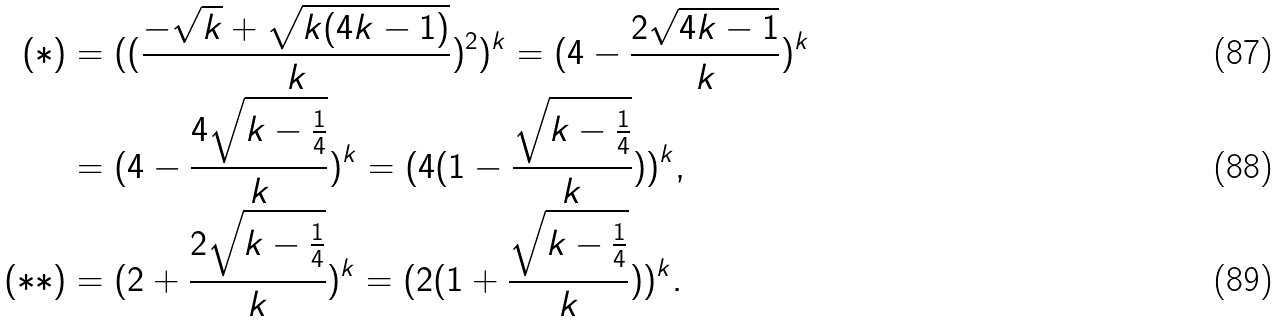<formula> <loc_0><loc_0><loc_500><loc_500>( * ) & = ( ( \frac { - \sqrt { k } + \sqrt { k ( 4 k - 1 ) } } { k } ) ^ { 2 } ) ^ { k } = ( 4 - \frac { 2 \sqrt { 4 k - 1 } } { k } ) ^ { k } \\ & = ( 4 - \frac { 4 \sqrt { k - \frac { 1 } { 4 } } } { k } ) ^ { k } = ( 4 ( 1 - \frac { \sqrt { k - \frac { 1 } { 4 } } } { k } ) ) ^ { k } , \\ ( * * ) & = ( 2 + \frac { 2 \sqrt { k - \frac { 1 } { 4 } } } { k } ) ^ { k } = ( 2 ( 1 + \frac { \sqrt { k - \frac { 1 } { 4 } } } { k } ) ) ^ { k } .</formula> 